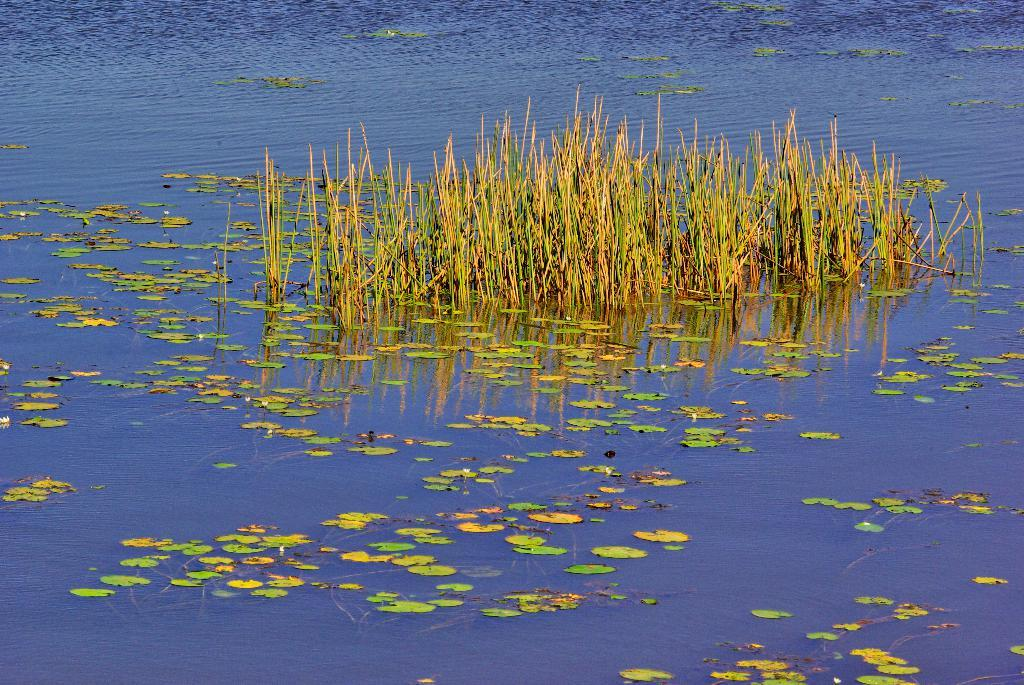What type of living organisms can be seen in the image? Plants and leaves are visible in the image. Where are the plants and leaves located? The plants and leaves are in a water body. What type of kettle can be seen floating among the plants and leaves in the image? There is no kettle present in the image; it features plants and leaves in a water body. How many robins can be seen perched on the leaves in the image? There are no robins present in the image; it only features plants and leaves in a water body. 